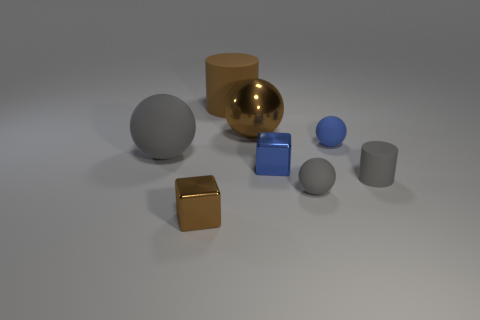Add 1 large purple things. How many objects exist? 9 Subtract all blocks. How many objects are left? 6 Subtract 0 green cubes. How many objects are left? 8 Subtract all gray things. Subtract all big brown metallic balls. How many objects are left? 4 Add 8 small brown metallic things. How many small brown metallic things are left? 9 Add 7 tiny gray metallic spheres. How many tiny gray metallic spheres exist? 7 